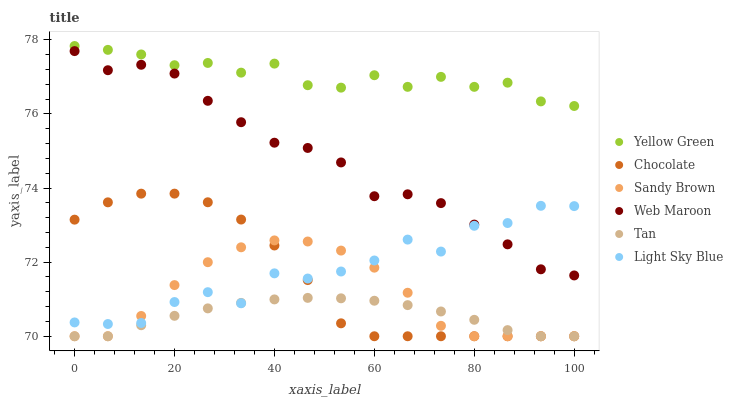Does Tan have the minimum area under the curve?
Answer yes or no. Yes. Does Yellow Green have the maximum area under the curve?
Answer yes or no. Yes. Does Web Maroon have the minimum area under the curve?
Answer yes or no. No. Does Web Maroon have the maximum area under the curve?
Answer yes or no. No. Is Tan the smoothest?
Answer yes or no. Yes. Is Light Sky Blue the roughest?
Answer yes or no. Yes. Is Web Maroon the smoothest?
Answer yes or no. No. Is Web Maroon the roughest?
Answer yes or no. No. Does Chocolate have the lowest value?
Answer yes or no. Yes. Does Web Maroon have the lowest value?
Answer yes or no. No. Does Yellow Green have the highest value?
Answer yes or no. Yes. Does Web Maroon have the highest value?
Answer yes or no. No. Is Chocolate less than Web Maroon?
Answer yes or no. Yes. Is Web Maroon greater than Chocolate?
Answer yes or no. Yes. Does Sandy Brown intersect Tan?
Answer yes or no. Yes. Is Sandy Brown less than Tan?
Answer yes or no. No. Is Sandy Brown greater than Tan?
Answer yes or no. No. Does Chocolate intersect Web Maroon?
Answer yes or no. No. 